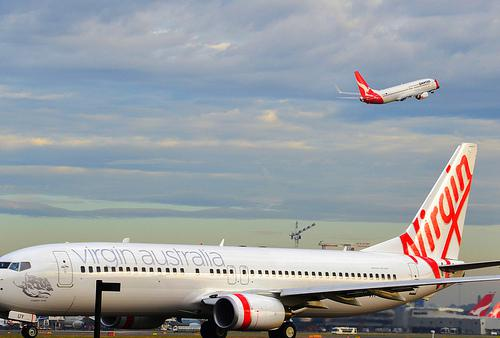Question: where is this scene?
Choices:
A. The park.
B. An airport.
C. A sidewalk.
D. A school.
Answer with the letter. Answer: B Question: why travel by plane?
Choices:
A. Quick.
B. Fast and economical.
C. It is cheaper.
D. It is safe.
Answer with the letter. Answer: B Question: what travels in the plane?
Choices:
A. People.
B. Workers.
C. Passengers.
D. Military.
Answer with the letter. Answer: C Question: what area is the plane parked?
Choices:
A. By the airport.
B. By the loading dock.
C. Tarmac.
D. Near the warehouse.
Answer with the letter. Answer: C Question: how is the plane powered?
Choices:
A. Propellers.
B. Jet engines.
C. Engines.
D. Air.
Answer with the letter. Answer: B Question: what company owns this plane?
Choices:
A. Delta.
B. Virgin Air.
C. American Airlines.
D. Southwest.
Answer with the letter. Answer: B Question: who flies the plane?
Choices:
A. A man.
B. A lady.
C. An engineer.
D. The pilot.
Answer with the letter. Answer: D 